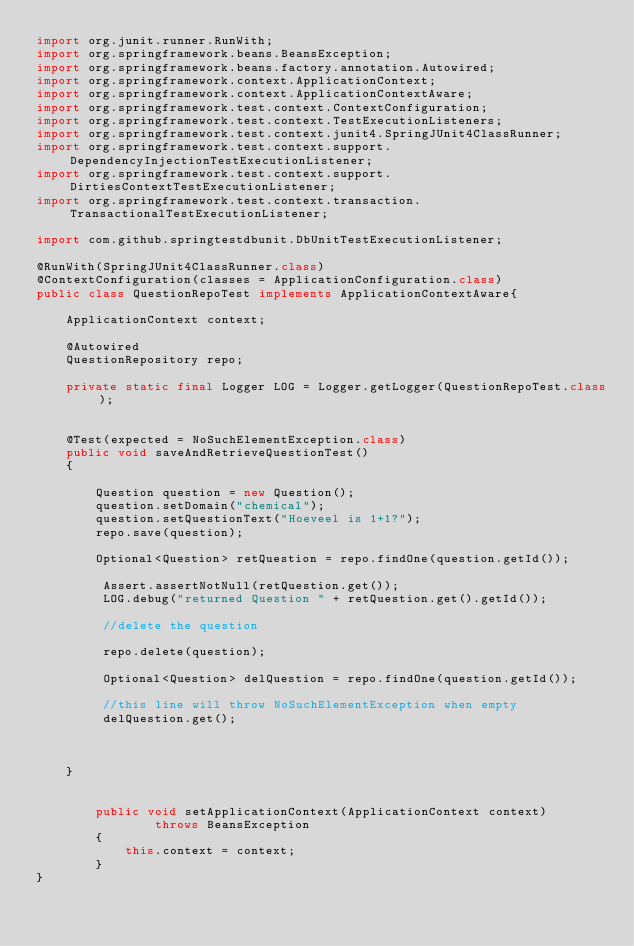Convert code to text. <code><loc_0><loc_0><loc_500><loc_500><_Java_>import org.junit.runner.RunWith;
import org.springframework.beans.BeansException;
import org.springframework.beans.factory.annotation.Autowired;
import org.springframework.context.ApplicationContext;
import org.springframework.context.ApplicationContextAware;
import org.springframework.test.context.ContextConfiguration;
import org.springframework.test.context.TestExecutionListeners;
import org.springframework.test.context.junit4.SpringJUnit4ClassRunner;
import org.springframework.test.context.support.DependencyInjectionTestExecutionListener;
import org.springframework.test.context.support.DirtiesContextTestExecutionListener;
import org.springframework.test.context.transaction.TransactionalTestExecutionListener;

import com.github.springtestdbunit.DbUnitTestExecutionListener;

@RunWith(SpringJUnit4ClassRunner.class)
@ContextConfiguration(classes = ApplicationConfiguration.class)
public class QuestionRepoTest implements ApplicationContextAware{

	ApplicationContext context;
	
	@Autowired
	QuestionRepository repo;
	
	private static final Logger LOG = Logger.getLogger(QuestionRepoTest.class);

	
	@Test(expected = NoSuchElementException.class)
	public void saveAndRetrieveQuestionTest()
	{
		
		Question question = new Question();
		question.setDomain("chemical");
		question.setQuestionText("Hoeveel is 1+1?");
		repo.save(question);
		
		Optional<Question> retQuestion = repo.findOne(question.getId());
		
		 Assert.assertNotNull(retQuestion.get());
		 LOG.debug("returned Question " + retQuestion.get().getId());
		 
		 //delete the question
		 
		 repo.delete(question);
		 
		 Optional<Question> delQuestion = repo.findOne(question.getId());
			
		 //this line will throw NoSuchElementException when empty
		 delQuestion.get();
		 
		
		
	}
	
	
	    public void setApplicationContext(ApplicationContext context)
	            throws BeansException
	    {
	        this.context = context;
	    }
}
</code> 